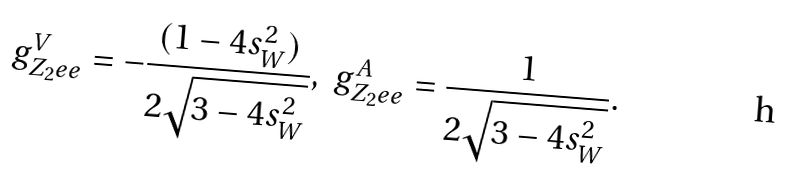Convert formula to latex. <formula><loc_0><loc_0><loc_500><loc_500>g ^ { V } _ { Z _ { 2 } e e } = - \frac { ( 1 - 4 s _ { W } ^ { 2 } ) } { 2 \sqrt { 3 - 4 s _ { W } ^ { 2 } } } , \ g ^ { A } _ { Z _ { 2 } e e } = \frac { 1 } { 2 \sqrt { 3 - 4 s _ { W } ^ { 2 } } } .</formula> 